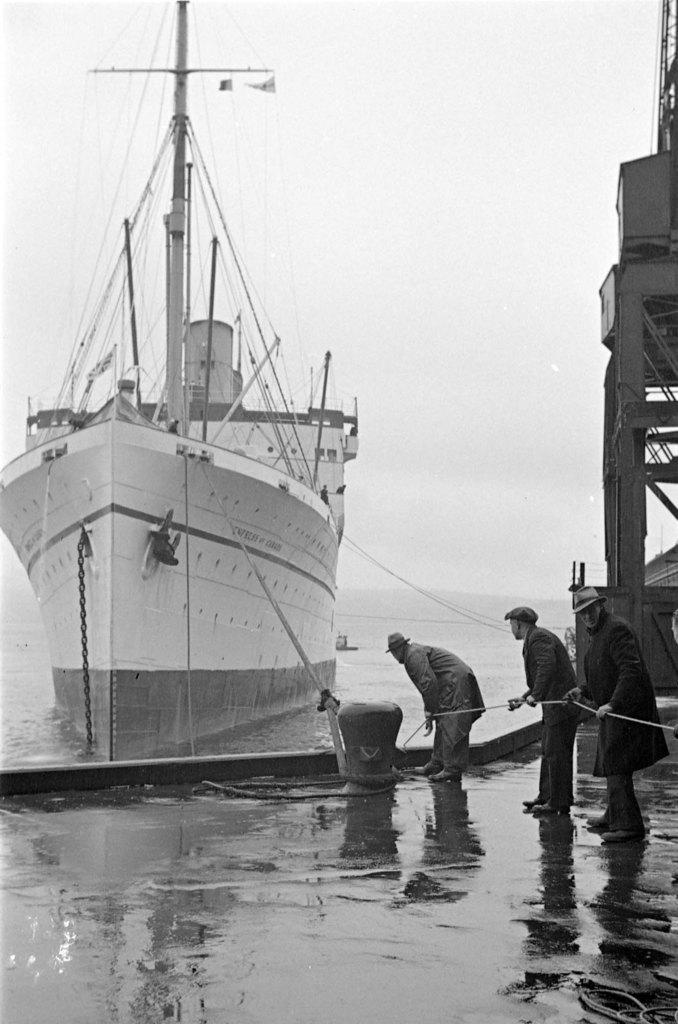Could you give a brief overview of what you see in this image? In the image I can see here is a ship on the water, beside that there are people standing on the harbor holding a rope which is connected with the ship. 